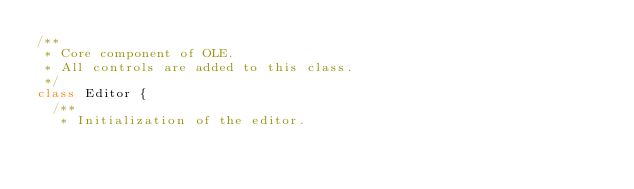Convert code to text. <code><loc_0><loc_0><loc_500><loc_500><_JavaScript_>/**
 * Core component of OLE.
 * All controls are added to this class.
 */
class Editor {
  /**
   * Initialization of the editor.</code> 